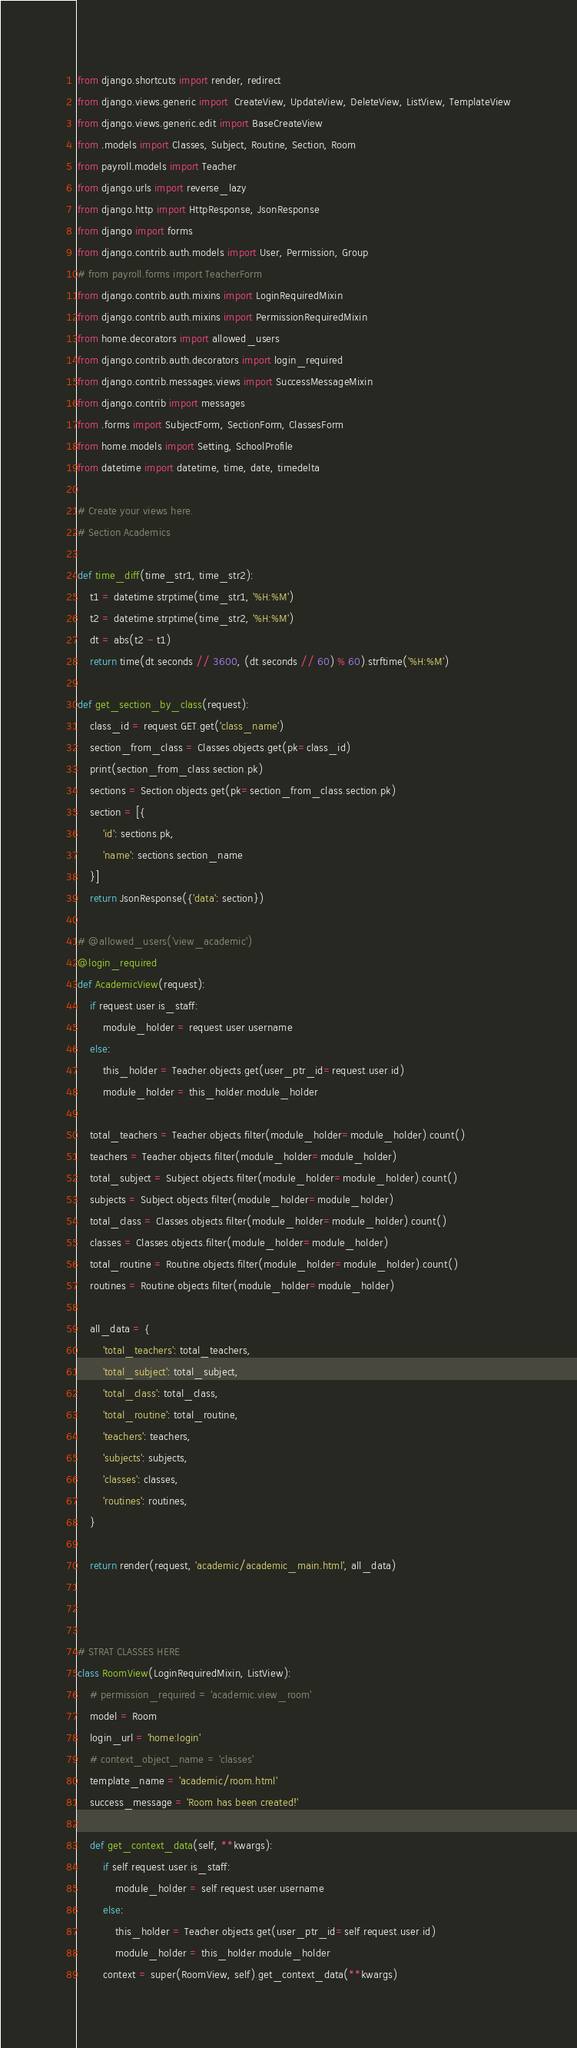Convert code to text. <code><loc_0><loc_0><loc_500><loc_500><_Python_>from django.shortcuts import render, redirect
from django.views.generic import  CreateView, UpdateView, DeleteView, ListView, TemplateView
from django.views.generic.edit import BaseCreateView
from .models import Classes, Subject, Routine, Section, Room
from payroll.models import Teacher
from django.urls import reverse_lazy
from django.http import HttpResponse, JsonResponse
from django import forms
from django.contrib.auth.models import User, Permission, Group
# from payroll.forms import TeacherForm
from django.contrib.auth.mixins import LoginRequiredMixin
from django.contrib.auth.mixins import PermissionRequiredMixin
from home.decorators import allowed_users
from django.contrib.auth.decorators import login_required
from django.contrib.messages.views import SuccessMessageMixin
from django.contrib import messages
from .forms import SubjectForm, SectionForm, ClassesForm
from home.models import Setting, SchoolProfile
from datetime import datetime, time, date, timedelta

# Create your views here.
# Section Academics

def time_diff(time_str1, time_str2):
    t1 = datetime.strptime(time_str1, '%H:%M')
    t2 = datetime.strptime(time_str2, '%H:%M')
    dt = abs(t2 - t1)
    return time(dt.seconds // 3600, (dt.seconds // 60) % 60).strftime('%H:%M')

def get_section_by_class(request):
    class_id = request.GET.get('class_name')
    section_from_class = Classes.objects.get(pk=class_id)
    print(section_from_class.section.pk)
    sections = Section.objects.get(pk=section_from_class.section.pk)
    section = [{
        'id': sections.pk,
        'name': sections.section_name
    }]
    return JsonResponse({'data': section})

# @allowed_users('view_academic')
@login_required
def AcademicView(request):
    if request.user.is_staff:
        module_holder = request.user.username
    else:
        this_holder = Teacher.objects.get(user_ptr_id=request.user.id)
        module_holder = this_holder.module_holder
    
    total_teachers = Teacher.objects.filter(module_holder=module_holder).count()
    teachers = Teacher.objects.filter(module_holder=module_holder)
    total_subject = Subject.objects.filter(module_holder=module_holder).count()
    subjects = Subject.objects.filter(module_holder=module_holder)
    total_class = Classes.objects.filter(module_holder=module_holder).count()
    classes = Classes.objects.filter(module_holder=module_holder)
    total_routine = Routine.objects.filter(module_holder=module_holder).count()
    routines = Routine.objects.filter(module_holder=module_holder)

    all_data = {
        'total_teachers': total_teachers,
        'total_subject': total_subject,
        'total_class': total_class,
        'total_routine': total_routine,
        'teachers': teachers,
        'subjects': subjects,
        'classes': classes,
        'routines': routines,
    }

    return render(request, 'academic/academic_main.html', all_data)
  


# STRAT CLASSES HERE
class RoomView(LoginRequiredMixin, ListView):
    # permission_required = 'academic.view_room'
    model = Room
    login_url = 'home:login'
    # context_object_name = 'classes'
    template_name = 'academic/room.html'
    success_message = 'Room has been created!'

    def get_context_data(self, **kwargs):
        if self.request.user.is_staff:
            module_holder = self.request.user.username
        else:
            this_holder = Teacher.objects.get(user_ptr_id=self.request.user.id)
            module_holder = this_holder.module_holder
        context = super(RoomView, self).get_context_data(**kwargs)</code> 